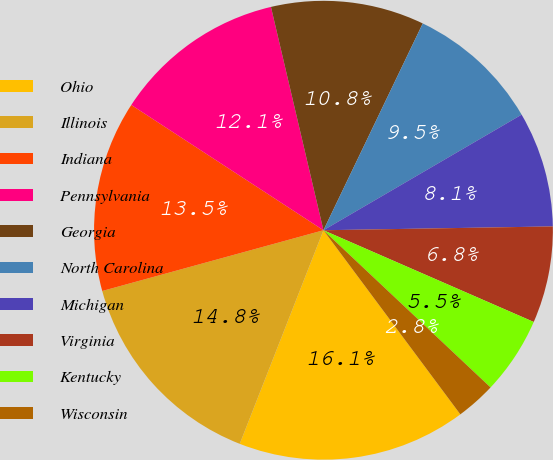<chart> <loc_0><loc_0><loc_500><loc_500><pie_chart><fcel>Ohio<fcel>Illinois<fcel>Indiana<fcel>Pennsylvania<fcel>Georgia<fcel>North Carolina<fcel>Michigan<fcel>Virginia<fcel>Kentucky<fcel>Wisconsin<nl><fcel>16.12%<fcel>14.79%<fcel>13.46%<fcel>12.13%<fcel>10.8%<fcel>9.47%<fcel>8.14%<fcel>6.81%<fcel>5.47%<fcel>2.81%<nl></chart> 